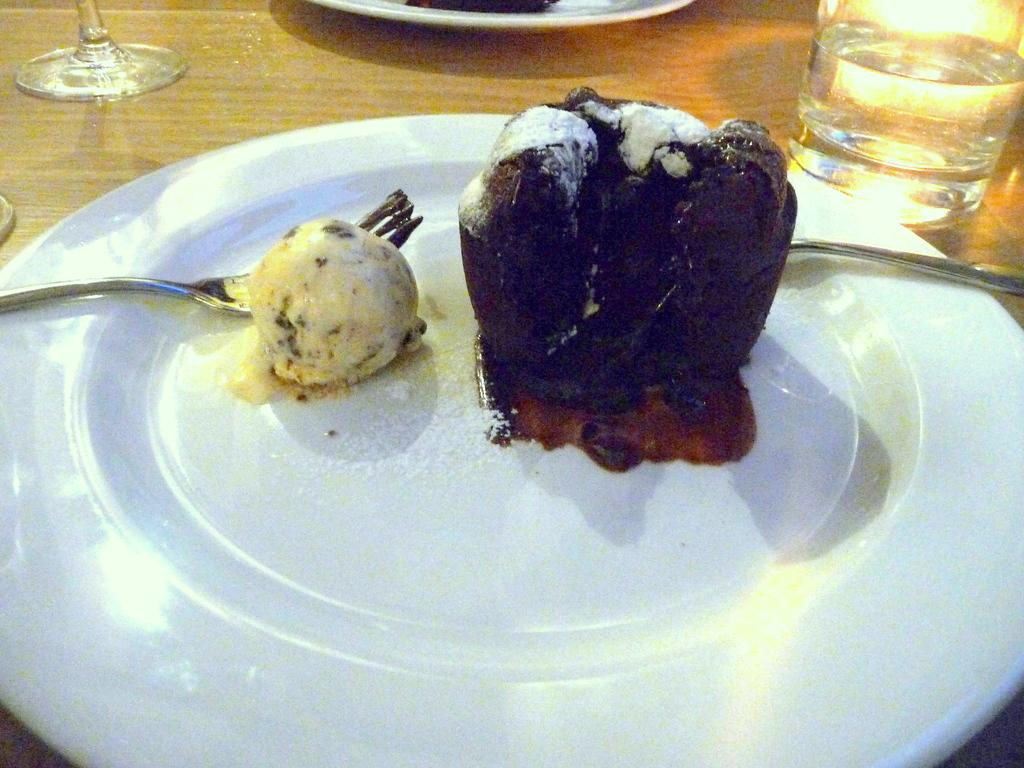What type of dessert can be seen in the image? There is a cake and ice cream in the image. How are the cake and ice cream arranged in the image? The cake and ice cream are on a plate in the image. What can be seen on either side of the plate? There are glasses on the left and right sides of the image. What type of furniture is present in the image? There is a wooden table in the image. What type of cap is the squirrel wearing in the image? There is no squirrel or cap present in the image. What invention is being demonstrated in the image? There is no invention being demonstrated in the image; it features a cake, ice cream, glasses, and a wooden table. 